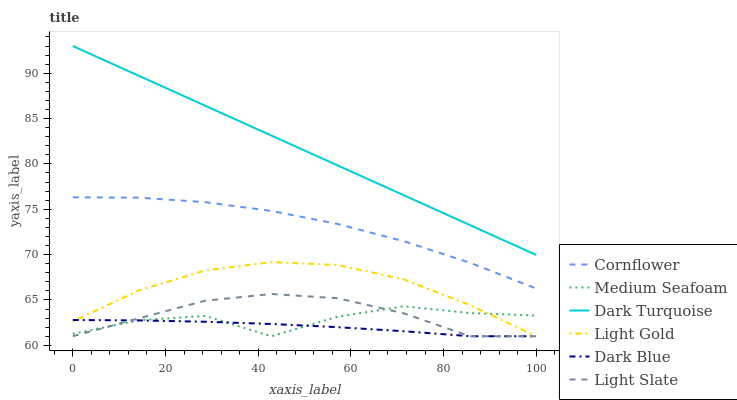Does Dark Blue have the minimum area under the curve?
Answer yes or no. Yes. Does Dark Turquoise have the maximum area under the curve?
Answer yes or no. Yes. Does Light Slate have the minimum area under the curve?
Answer yes or no. No. Does Light Slate have the maximum area under the curve?
Answer yes or no. No. Is Dark Turquoise the smoothest?
Answer yes or no. Yes. Is Medium Seafoam the roughest?
Answer yes or no. Yes. Is Light Slate the smoothest?
Answer yes or no. No. Is Light Slate the roughest?
Answer yes or no. No. Does Light Slate have the lowest value?
Answer yes or no. Yes. Does Dark Turquoise have the lowest value?
Answer yes or no. No. Does Dark Turquoise have the highest value?
Answer yes or no. Yes. Does Light Slate have the highest value?
Answer yes or no. No. Is Dark Blue less than Cornflower?
Answer yes or no. Yes. Is Dark Turquoise greater than Cornflower?
Answer yes or no. Yes. Does Light Slate intersect Dark Blue?
Answer yes or no. Yes. Is Light Slate less than Dark Blue?
Answer yes or no. No. Is Light Slate greater than Dark Blue?
Answer yes or no. No. Does Dark Blue intersect Cornflower?
Answer yes or no. No. 